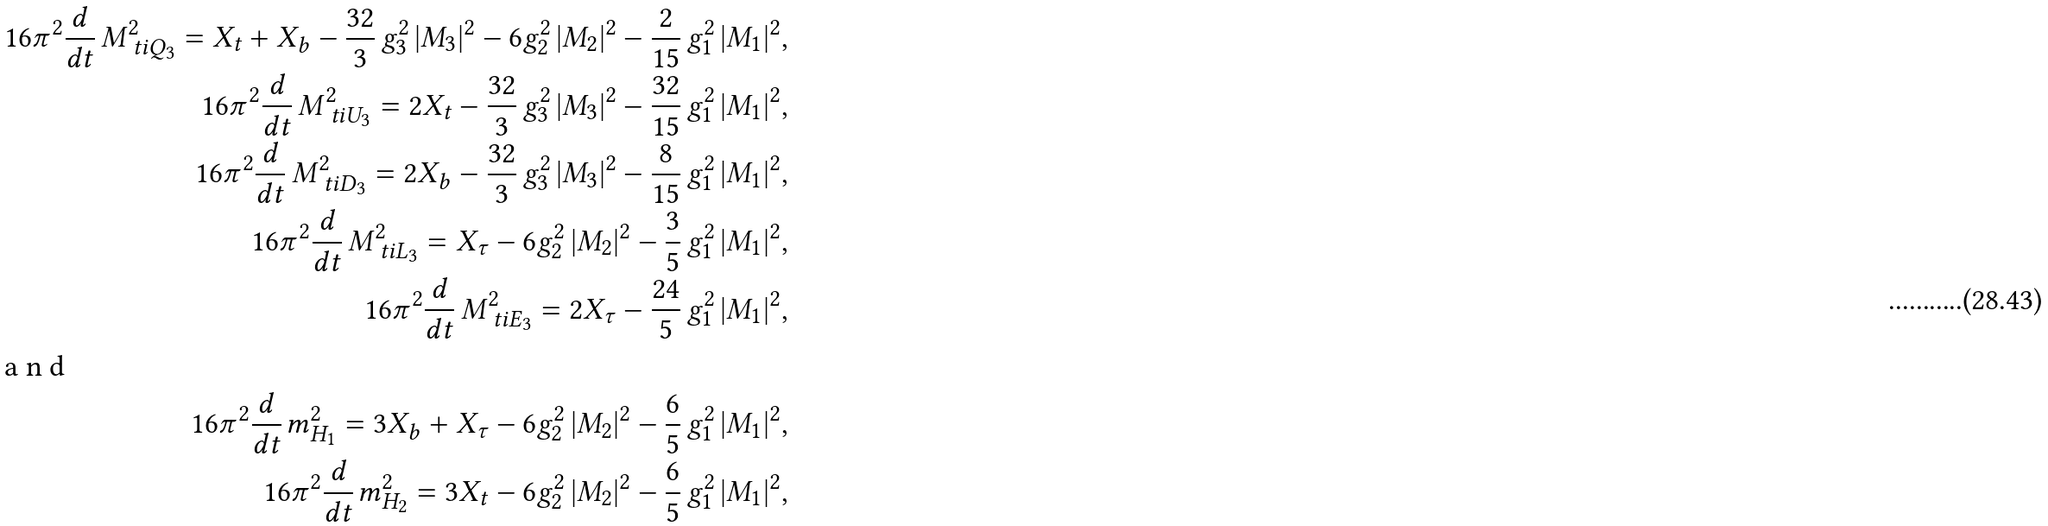<formula> <loc_0><loc_0><loc_500><loc_500>1 6 \pi ^ { 2 } \frac { d } { d t } \, M _ { \ t i Q _ { 3 } } ^ { 2 } = X _ { t } + X _ { b } - \frac { 3 2 } { 3 } \, g _ { 3 } ^ { 2 } \, | M _ { 3 } | ^ { 2 } - 6 g _ { 2 } ^ { 2 } \, | M _ { 2 } | ^ { 2 } - \frac { 2 } { 1 5 } \, g _ { 1 } ^ { 2 } \, | M _ { 1 } | ^ { 2 } , \\ 1 6 \pi ^ { 2 } \frac { d } { d t } \, M _ { \ t i U _ { 3 } } ^ { 2 } = 2 X _ { t } - \frac { 3 2 } { 3 } \, g _ { 3 } ^ { 2 } \, | M _ { 3 } | ^ { 2 } - \frac { 3 2 } { 1 5 } \, g _ { 1 } ^ { 2 } \, | M _ { 1 } | ^ { 2 } , \\ 1 6 \pi ^ { 2 } \frac { d } { d t } \, M _ { \ t i D _ { 3 } } ^ { 2 } = 2 X _ { b } - \frac { 3 2 } { 3 } \, g _ { 3 } ^ { 2 } \, | M _ { 3 } | ^ { 2 } - \frac { 8 } { 1 5 } \, g _ { 1 } ^ { 2 } \, | M _ { 1 } | ^ { 2 } , \\ 1 6 \pi ^ { 2 } \frac { d } { d t } \, M _ { \ t i L _ { 3 } } ^ { 2 } = X _ { \tau } - 6 g _ { 2 } ^ { 2 } \, | M _ { 2 } | ^ { 2 } - \frac { 3 } { 5 } \, g _ { 1 } ^ { 2 } \, | M _ { 1 } | ^ { 2 } , \\ 1 6 \pi ^ { 2 } \frac { d } { d t } \, M _ { \ t i E _ { 3 } } ^ { 2 } = 2 X _ { \tau } - \frac { 2 4 } { 5 } \, g _ { 1 } ^ { 2 } \, | M _ { 1 } | ^ { 2 } , \\ \intertext { a n d } 1 6 \pi ^ { 2 } \frac { d } { d t } \, m _ { H _ { 1 } } ^ { 2 } = 3 X _ { b } + X _ { \tau } - 6 g _ { 2 } ^ { 2 } \, | M _ { 2 } | ^ { 2 } - \frac { 6 } { 5 } \, g _ { 1 } ^ { 2 } \, | M _ { 1 } | ^ { 2 } , \\ 1 6 \pi ^ { 2 } \frac { d } { d t } \, m _ { H _ { 2 } } ^ { 2 } = 3 X _ { t } - 6 g _ { 2 } ^ { 2 } \, | M _ { 2 } | ^ { 2 } - \frac { 6 } { 5 } \, g _ { 1 } ^ { 2 } \, | M _ { 1 } | ^ { 2 } ,</formula> 